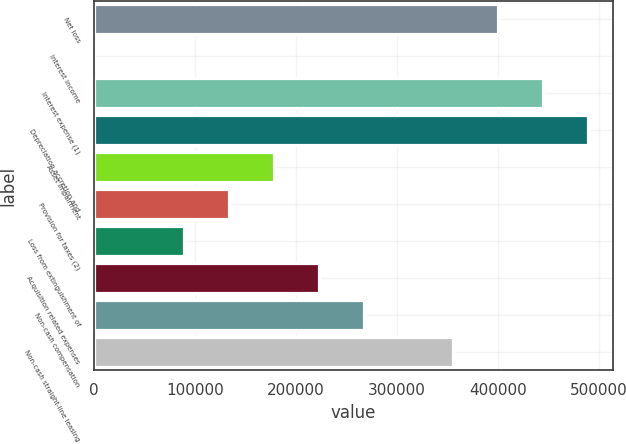Convert chart. <chart><loc_0><loc_0><loc_500><loc_500><bar_chart><fcel>Net loss<fcel>Interest income<fcel>Interest expense (1)<fcel>Depreciation accretion and<fcel>Asset impairment<fcel>Provision for taxes (2)<fcel>Loss from extinguishment of<fcel>Acquisition related expenses<fcel>Non-cash compensation<fcel>Non-cash straight-line leasing<nl><fcel>400439<fcel>136<fcel>444917<fcel>489395<fcel>178048<fcel>133570<fcel>89092.2<fcel>222526<fcel>267005<fcel>355961<nl></chart> 